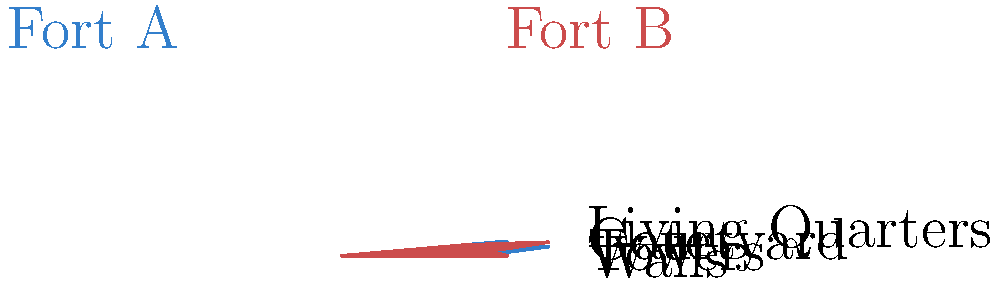The polar graph compares the architectural layouts of two traditional Omani forts, Fort A and Fort B. Based on the graph, which fort has a more prominent defensive feature in terms of its walls? To determine which fort has a more prominent defensive feature in terms of its walls, we need to analyze the polar graph:

1. The graph represents five key architectural elements: Walls, Towers, Courtyard, Gate, and Living Quarters.
2. Each element is plotted on a radial axis, with the distance from the center indicating its prominence or size.
3. Fort A is represented by the blue polygon, while Fort B is represented by the red polygon.
4. We need to focus on the "Walls" axis, which is the topmost point of the graph.
5. For Fort A (blue), the walls extend to approximately 3 units on the radial axis.
6. For Fort B (red), the walls extend to approximately 4 units on the radial axis.
7. Since Fort B's walls extend further on the radial axis, it indicates that Fort B has more prominent walls compared to Fort A.

Therefore, Fort B has a more prominent defensive feature in terms of its walls.
Answer: Fort B 